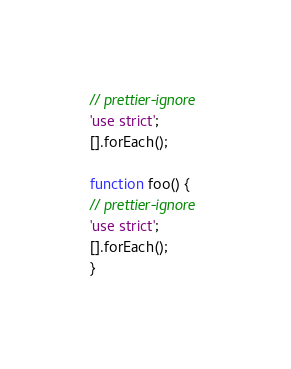<code> <loc_0><loc_0><loc_500><loc_500><_JavaScript_>// prettier-ignore
'use strict';
[].forEach();

function foo() {
// prettier-ignore
'use strict';
[].forEach();
}
</code> 